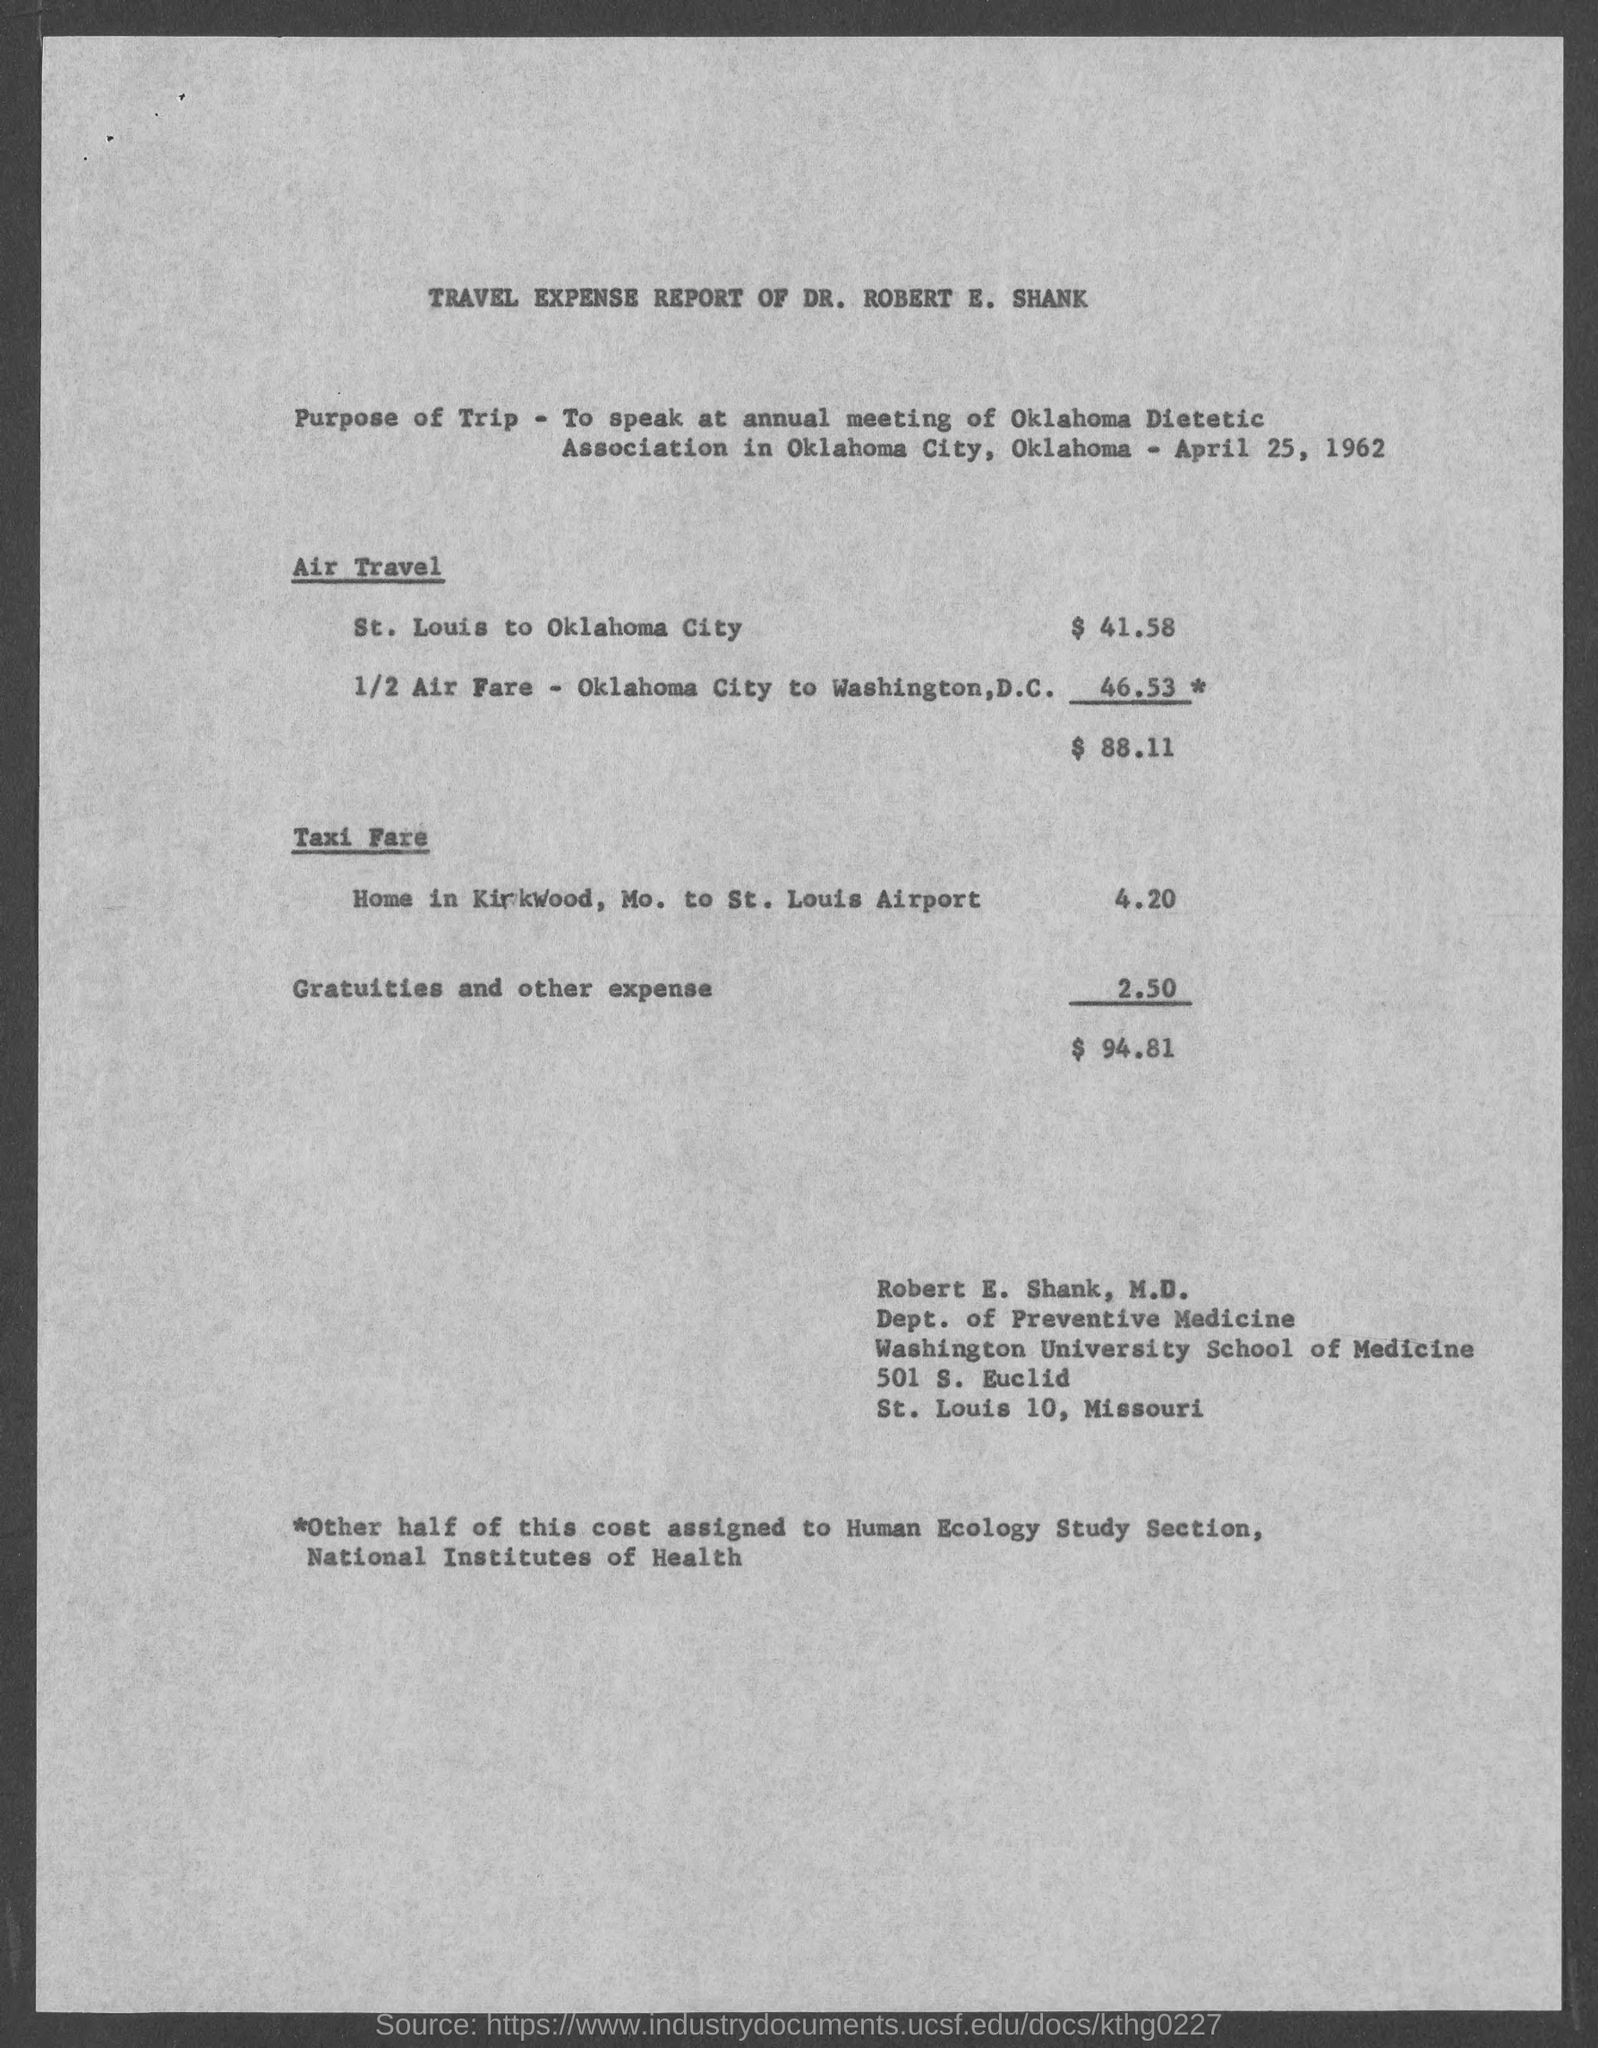Outline some significant characteristics in this image. The air travel expense from St. Louis to Oklahoma City is 41.58 dollars. The meeting was held on April 25, 1962. The document pertains to the travel expenses incurred by Dr. Robert E. Shank during a specific period. At the annual meeting of the Oklahoma Dietetic Association, Dr. Robert spoke. 